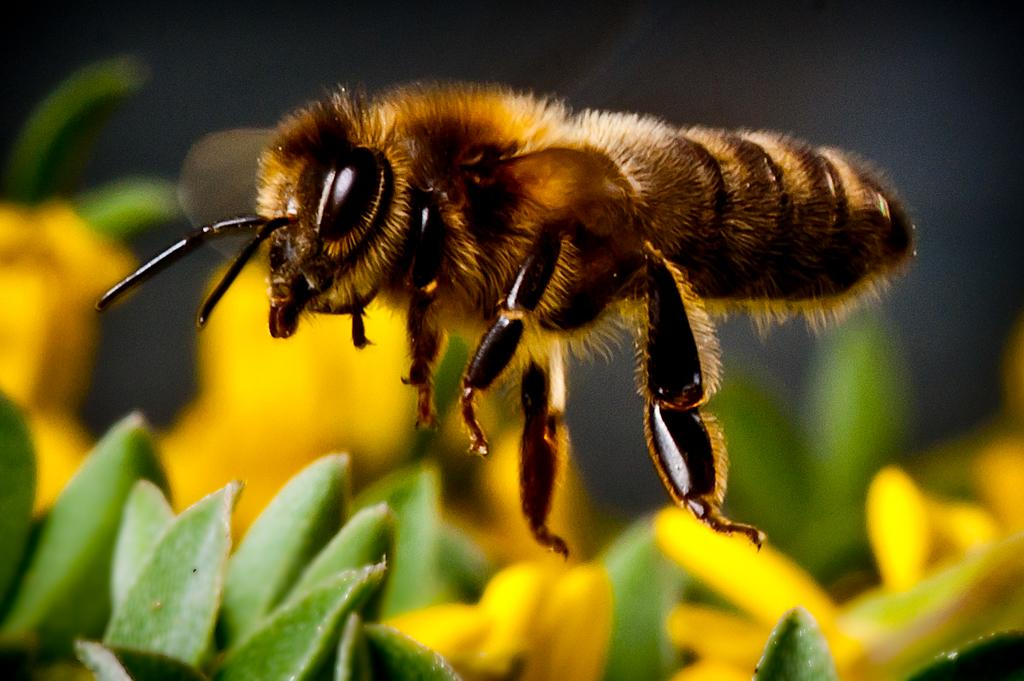What type of insect is present in the image? There is a honey bee in the image. What is the honey bee doing in the image? The honey bee is flying in the air. What can be seen in the image besides the honey bee? There are flowers in the image. What type of society is depicted in the image? There is no society depicted in the image; it features a honey bee flying near flowers. What letters can be seen on the honey bee in the image? There are no letters present on the honey bee in the image. 